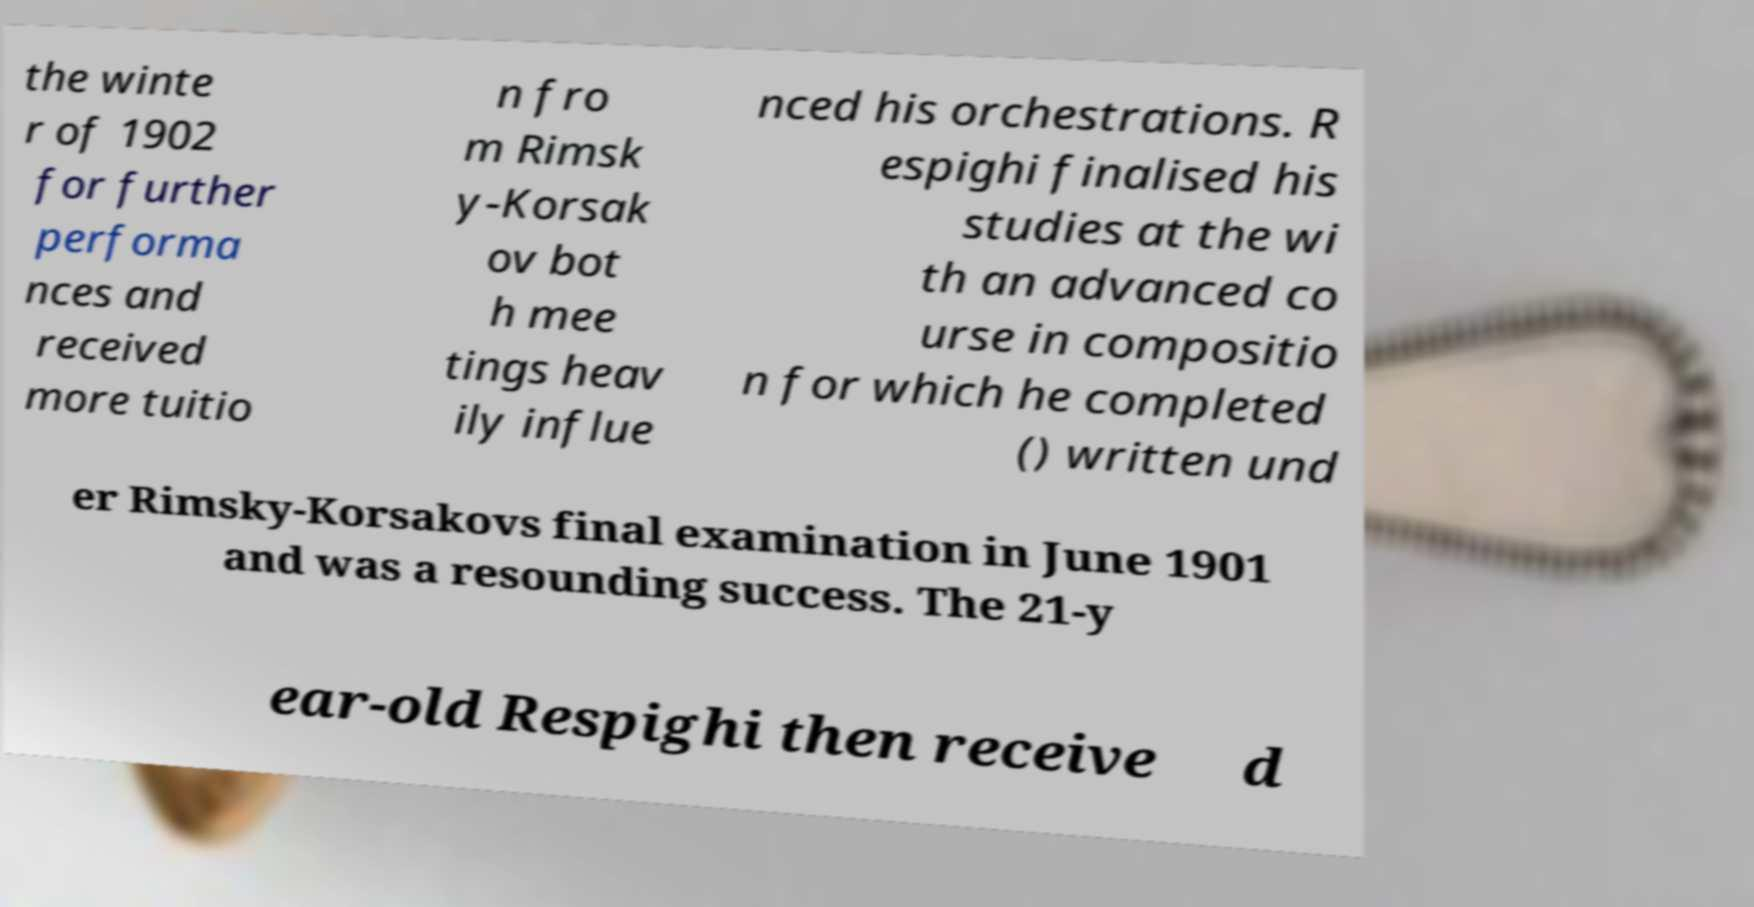Can you read and provide the text displayed in the image?This photo seems to have some interesting text. Can you extract and type it out for me? the winte r of 1902 for further performa nces and received more tuitio n fro m Rimsk y-Korsak ov bot h mee tings heav ily influe nced his orchestrations. R espighi finalised his studies at the wi th an advanced co urse in compositio n for which he completed () written und er Rimsky-Korsakovs final examination in June 1901 and was a resounding success. The 21-y ear-old Respighi then receive d 